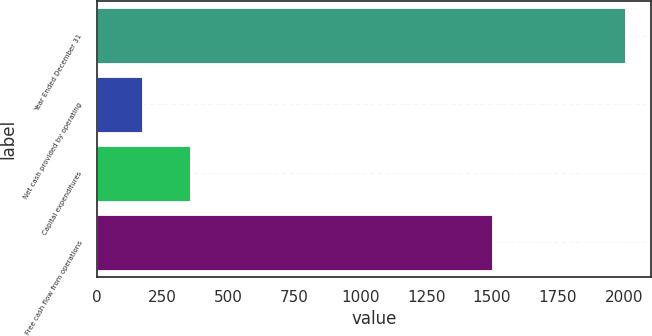<chart> <loc_0><loc_0><loc_500><loc_500><bar_chart><fcel>Year Ended December 31<fcel>Net cash provided by operating<fcel>Capital expenditures<fcel>Free cash flow from operations<nl><fcel>2003<fcel>172<fcel>355.1<fcel>1501<nl></chart> 